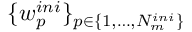<formula> <loc_0><loc_0><loc_500><loc_500>\{ w _ { p } ^ { i n i } \} _ { p \in \{ 1 , \dots , N _ { m } ^ { i n i } \} }</formula> 